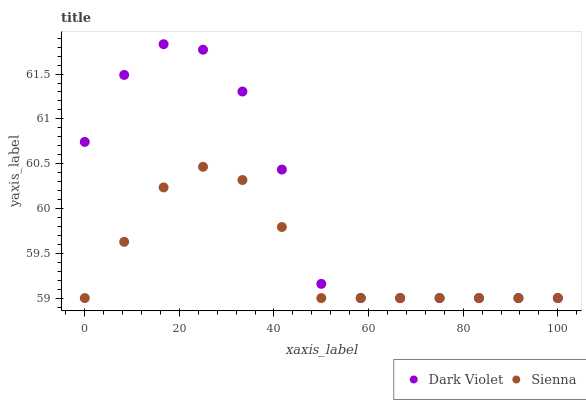Does Sienna have the minimum area under the curve?
Answer yes or no. Yes. Does Dark Violet have the maximum area under the curve?
Answer yes or no. Yes. Does Dark Violet have the minimum area under the curve?
Answer yes or no. No. Is Sienna the smoothest?
Answer yes or no. Yes. Is Dark Violet the roughest?
Answer yes or no. Yes. Is Dark Violet the smoothest?
Answer yes or no. No. Does Sienna have the lowest value?
Answer yes or no. Yes. Does Dark Violet have the highest value?
Answer yes or no. Yes. Does Sienna intersect Dark Violet?
Answer yes or no. Yes. Is Sienna less than Dark Violet?
Answer yes or no. No. Is Sienna greater than Dark Violet?
Answer yes or no. No. 